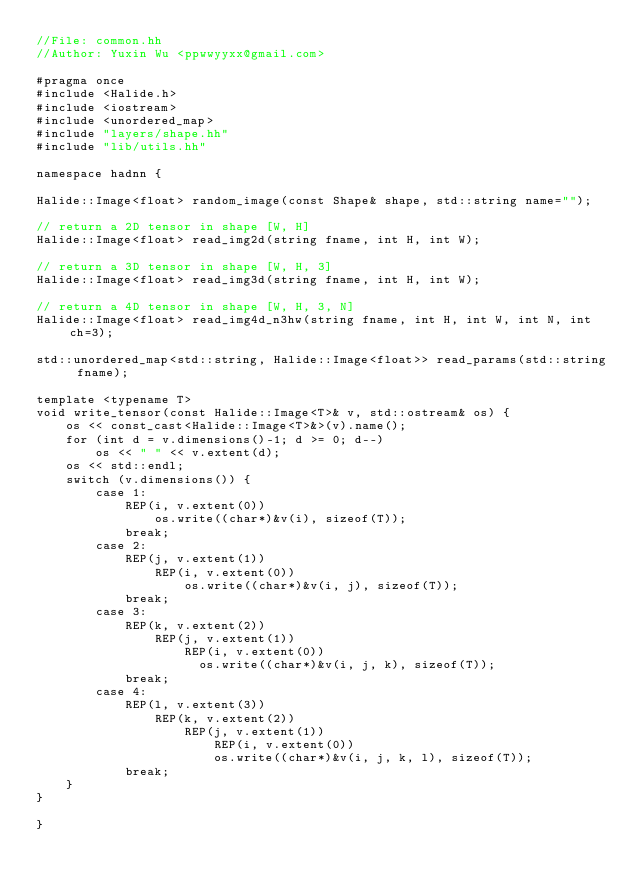<code> <loc_0><loc_0><loc_500><loc_500><_C++_>//File: common.hh
//Author: Yuxin Wu <ppwwyyxx@gmail.com>

#pragma once
#include <Halide.h>
#include <iostream>
#include <unordered_map>
#include "layers/shape.hh"
#include "lib/utils.hh"

namespace hadnn {

Halide::Image<float> random_image(const Shape& shape, std::string name="");

// return a 2D tensor in shape [W, H]
Halide::Image<float> read_img2d(string fname, int H, int W);

// return a 3D tensor in shape [W, H, 3]
Halide::Image<float> read_img3d(string fname, int H, int W);

// return a 4D tensor in shape [W, H, 3, N]
Halide::Image<float> read_img4d_n3hw(string fname, int H, int W, int N, int ch=3);

std::unordered_map<std::string, Halide::Image<float>> read_params(std::string fname);

template <typename T>
void write_tensor(const Halide::Image<T>& v, std::ostream& os) {
	os << const_cast<Halide::Image<T>&>(v).name();
	for (int d = v.dimensions()-1; d >= 0; d--)
		os << " " << v.extent(d);
	os << std::endl;
	switch (v.dimensions()) {
		case 1:
			REP(i, v.extent(0))
				os.write((char*)&v(i), sizeof(T));
			break;
		case 2:
			REP(j, v.extent(1))
				REP(i, v.extent(0))
					os.write((char*)&v(i, j), sizeof(T));
			break;
		case 3:
			REP(k, v.extent(2))
				REP(j, v.extent(1))
					REP(i, v.extent(0))
					  os.write((char*)&v(i, j, k), sizeof(T));
			break;
		case 4:
			REP(l, v.extent(3))
				REP(k, v.extent(2))
					REP(j, v.extent(1))
						REP(i, v.extent(0))
					    os.write((char*)&v(i, j, k, l), sizeof(T));
			break;
	}
}

}
</code> 